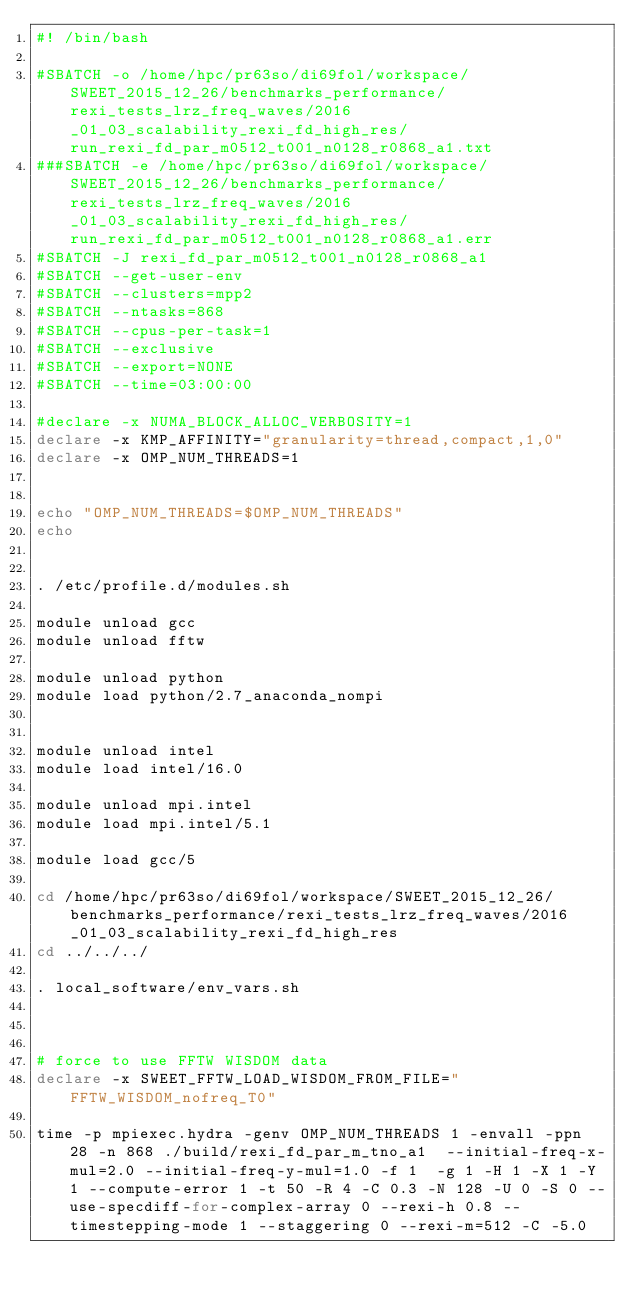Convert code to text. <code><loc_0><loc_0><loc_500><loc_500><_Bash_>#! /bin/bash

#SBATCH -o /home/hpc/pr63so/di69fol/workspace/SWEET_2015_12_26/benchmarks_performance/rexi_tests_lrz_freq_waves/2016_01_03_scalability_rexi_fd_high_res/run_rexi_fd_par_m0512_t001_n0128_r0868_a1.txt
###SBATCH -e /home/hpc/pr63so/di69fol/workspace/SWEET_2015_12_26/benchmarks_performance/rexi_tests_lrz_freq_waves/2016_01_03_scalability_rexi_fd_high_res/run_rexi_fd_par_m0512_t001_n0128_r0868_a1.err
#SBATCH -J rexi_fd_par_m0512_t001_n0128_r0868_a1
#SBATCH --get-user-env
#SBATCH --clusters=mpp2
#SBATCH --ntasks=868
#SBATCH --cpus-per-task=1
#SBATCH --exclusive
#SBATCH --export=NONE
#SBATCH --time=03:00:00

#declare -x NUMA_BLOCK_ALLOC_VERBOSITY=1
declare -x KMP_AFFINITY="granularity=thread,compact,1,0"
declare -x OMP_NUM_THREADS=1


echo "OMP_NUM_THREADS=$OMP_NUM_THREADS"
echo


. /etc/profile.d/modules.sh

module unload gcc
module unload fftw

module unload python
module load python/2.7_anaconda_nompi


module unload intel
module load intel/16.0

module unload mpi.intel
module load mpi.intel/5.1

module load gcc/5

cd /home/hpc/pr63so/di69fol/workspace/SWEET_2015_12_26/benchmarks_performance/rexi_tests_lrz_freq_waves/2016_01_03_scalability_rexi_fd_high_res
cd ../../../

. local_software/env_vars.sh



# force to use FFTW WISDOM data
declare -x SWEET_FFTW_LOAD_WISDOM_FROM_FILE="FFTW_WISDOM_nofreq_T0"

time -p mpiexec.hydra -genv OMP_NUM_THREADS 1 -envall -ppn 28 -n 868 ./build/rexi_fd_par_m_tno_a1  --initial-freq-x-mul=2.0 --initial-freq-y-mul=1.0 -f 1  -g 1 -H 1 -X 1 -Y 1 --compute-error 1 -t 50 -R 4 -C 0.3 -N 128 -U 0 -S 0 --use-specdiff-for-complex-array 0 --rexi-h 0.8 --timestepping-mode 1 --staggering 0 --rexi-m=512 -C -5.0

</code> 